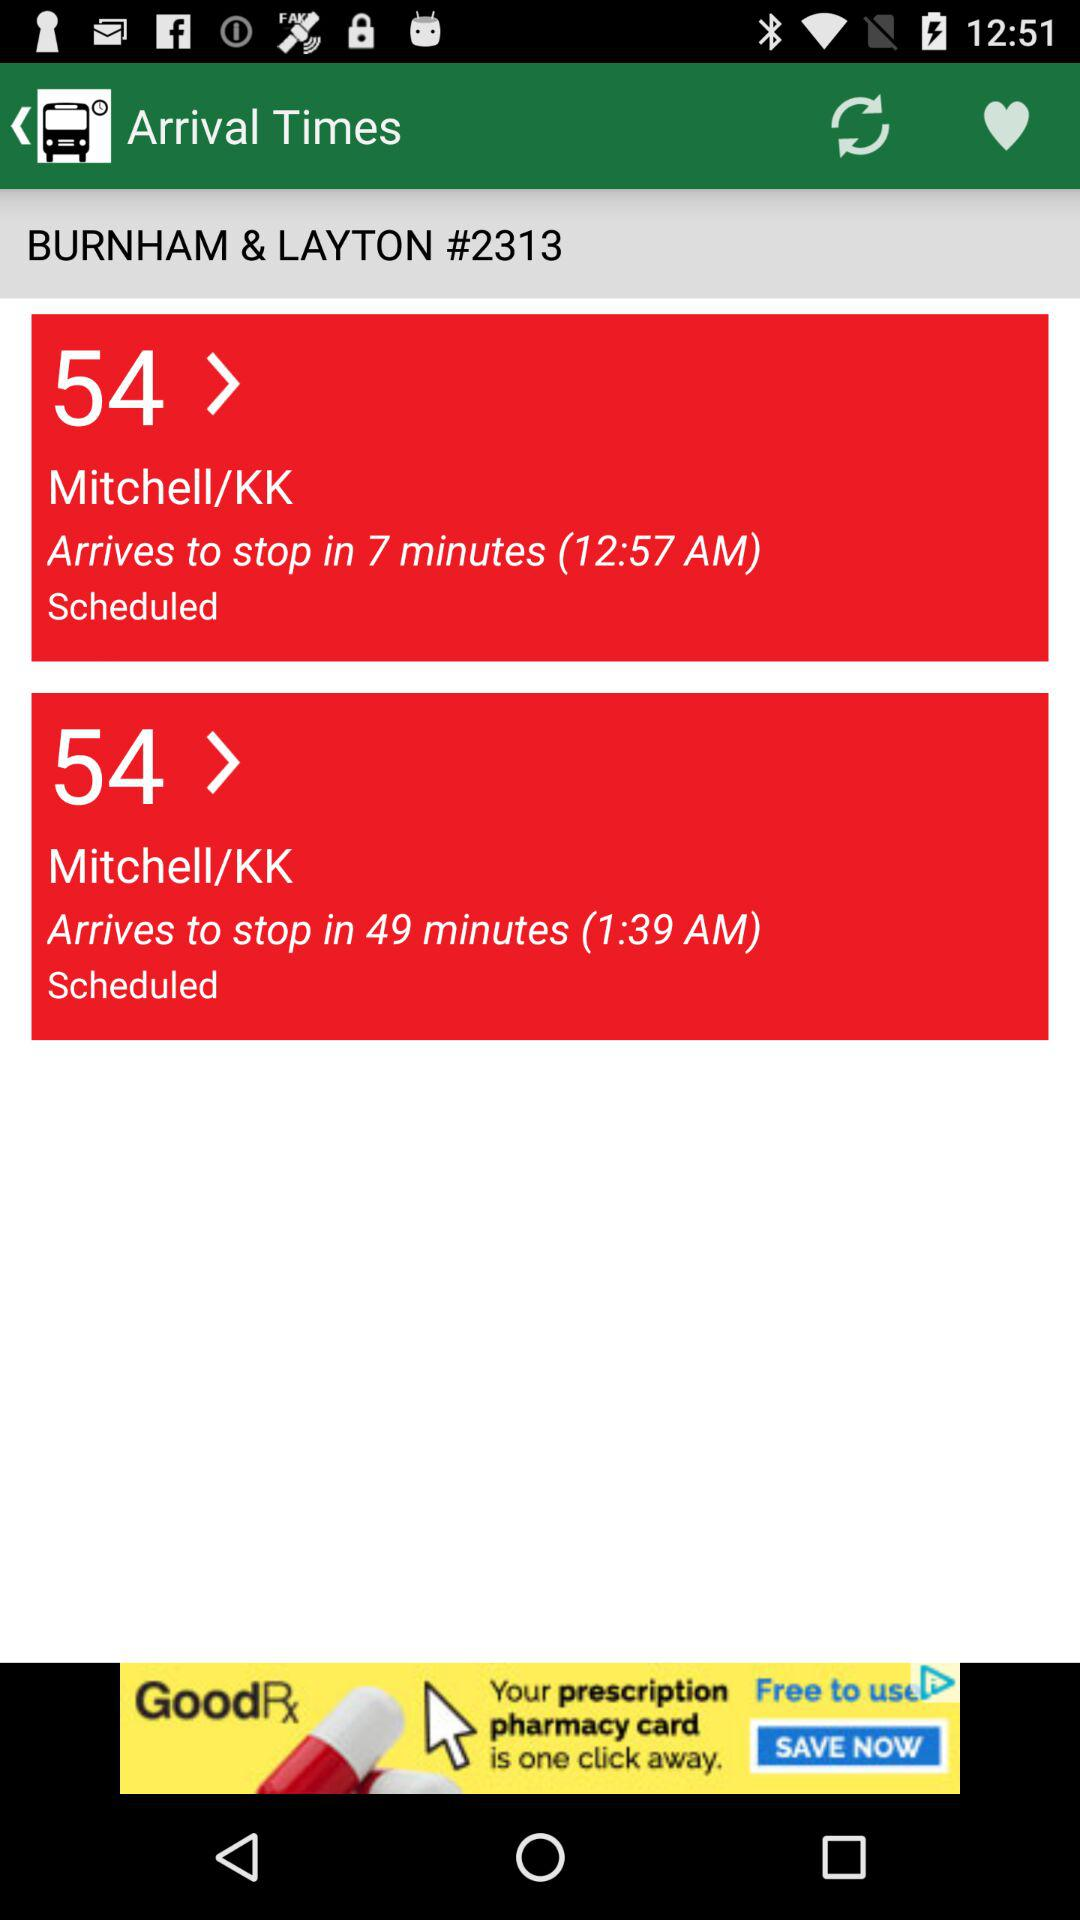What is the arrival time at the stop? The arrival times are 12:57 AM and 1:39 AM. 